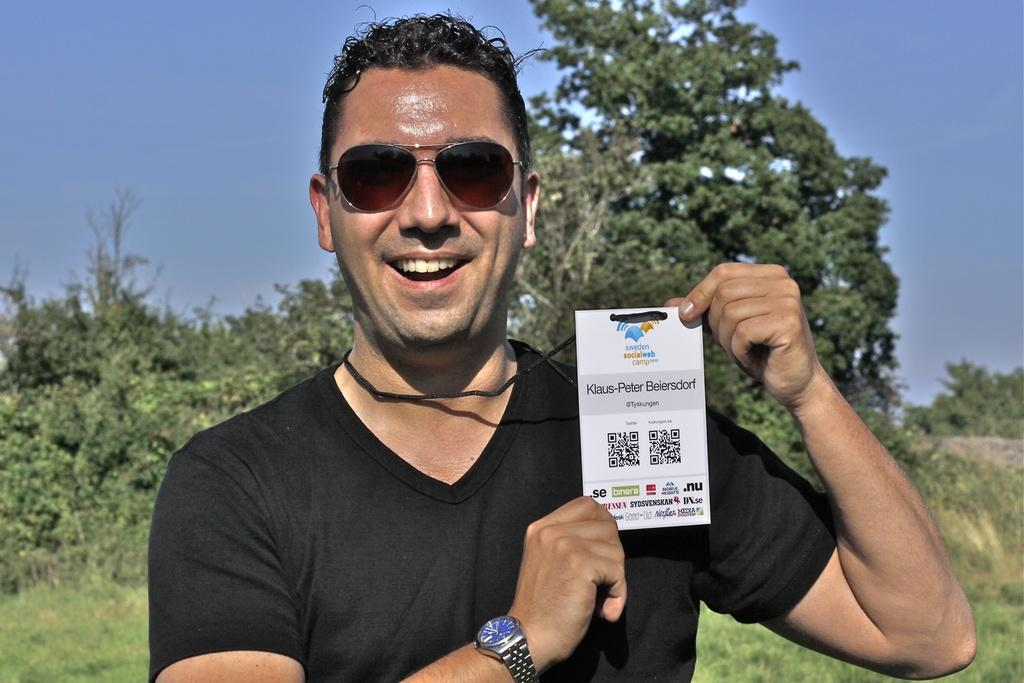What is present in the image? There is a person in the image. Can you describe the person's appearance? The person is wearing specs and a watch. What is the person holding in the image? The person is holding a tag. What can be seen in the background of the image? There are trees and the sky visible in the background of the image. Where is the flame coming from in the image? There is no flame present in the image. What type of grain is visible on the tray in the image? There is no tray or grain present in the image. 